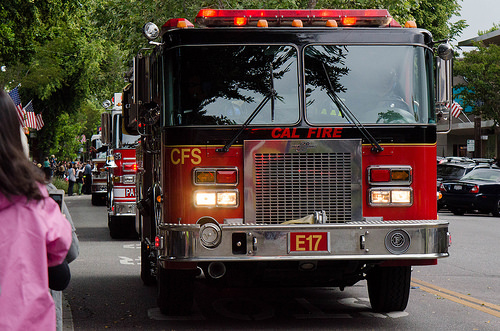<image>
Is there a fire truck to the left of the street? No. The fire truck is not to the left of the street. From this viewpoint, they have a different horizontal relationship. 